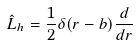<formula> <loc_0><loc_0><loc_500><loc_500>\hat { L } _ { h } = \frac { 1 } { 2 } \delta ( r - b ) \frac { d } { d r }</formula> 